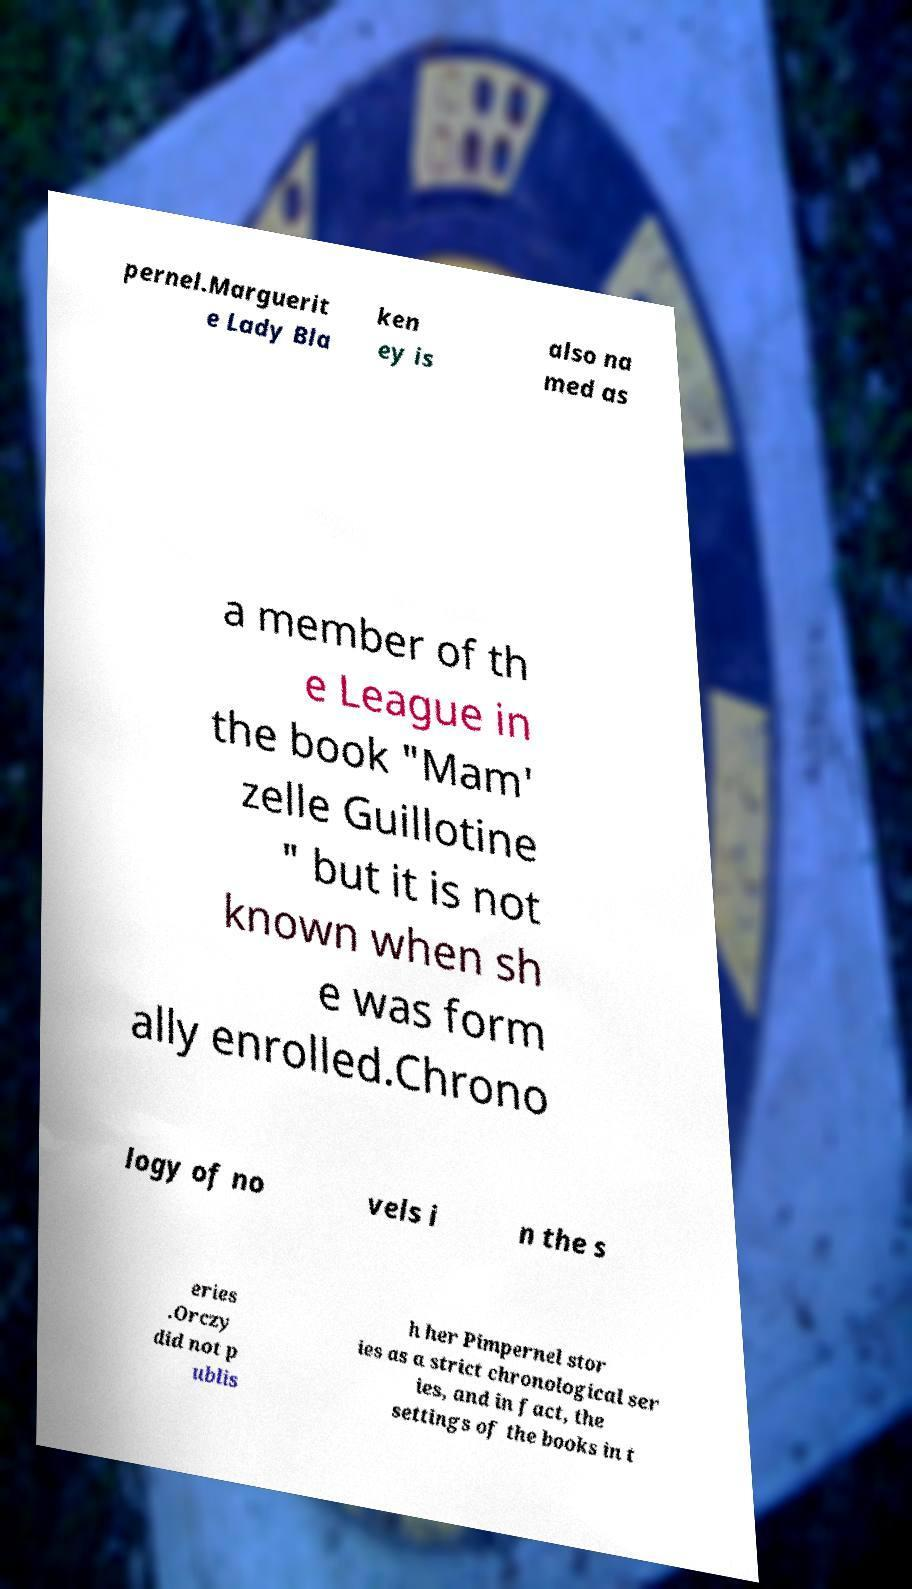There's text embedded in this image that I need extracted. Can you transcribe it verbatim? pernel.Marguerit e Lady Bla ken ey is also na med as a member of th e League in the book "Mam' zelle Guillotine " but it is not known when sh e was form ally enrolled.Chrono logy of no vels i n the s eries .Orczy did not p ublis h her Pimpernel stor ies as a strict chronological ser ies, and in fact, the settings of the books in t 